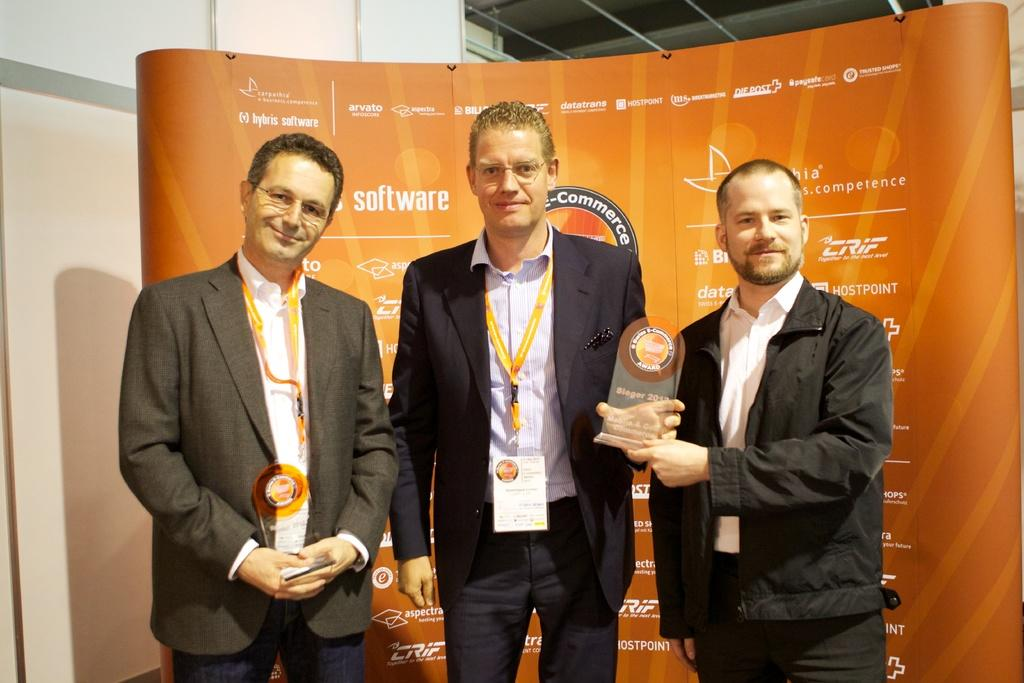How many people are in the image? There are three men in the image. What are the men doing in the image? The men are standing and holding a trophy. What can be seen in the background of the image? There is a banner and a wall in the background of the image. What type of grain is visible on the wall in the image? There is no grain visible on the wall in the image. How many muscles can be seen on the men in the image? The image does not show the men's muscles, so it cannot be determined how many muscles are visible. 